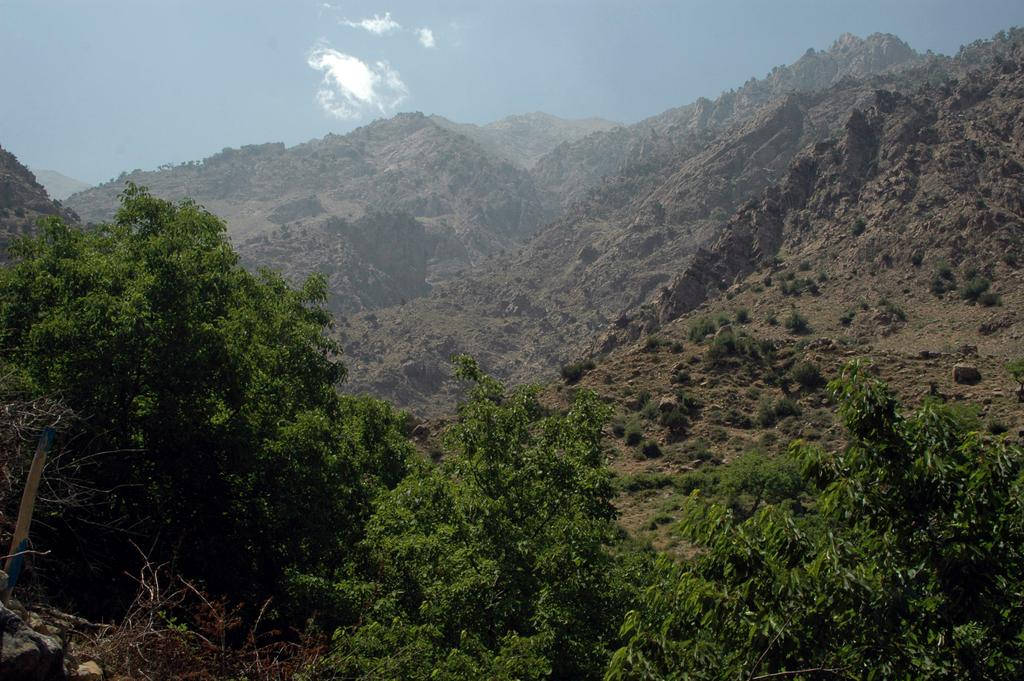What type of vegetation is at the bottom of the image? There are trees at the bottom of the image. What type of natural landforms can be seen in the background of the image? There are mountains in the background of the image. What other type of vegetation is visible in the background of the image? There are plants in the background of the image. What is visible at the top of the image? The sky is visible at the top of the image. What type of error can be seen in the image? There is no error present in the image. What type of arch can be seen in the image? There is no arch present in the image. 